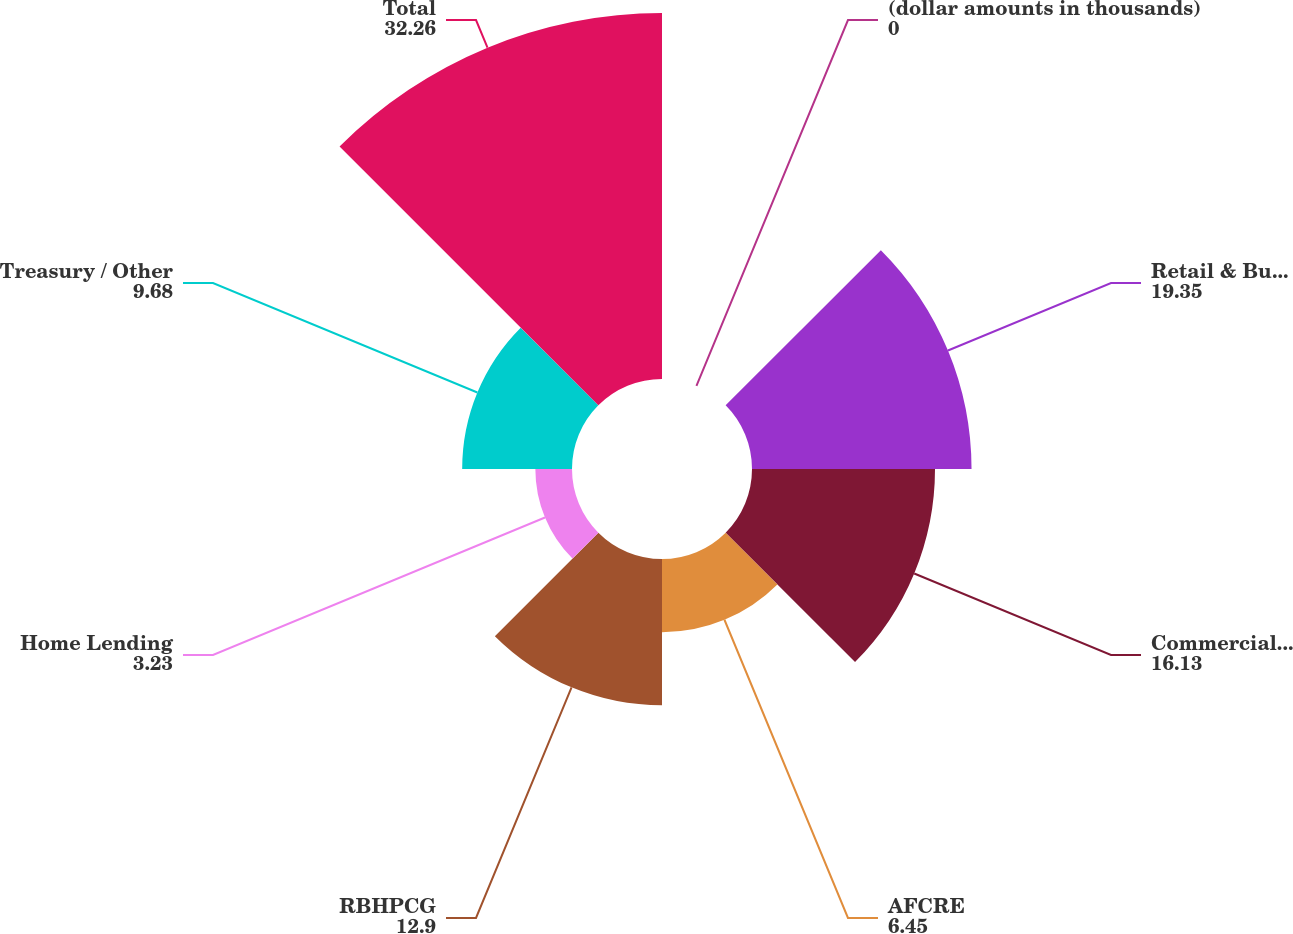<chart> <loc_0><loc_0><loc_500><loc_500><pie_chart><fcel>(dollar amounts in thousands)<fcel>Retail & Business Banking<fcel>Commercial Banking<fcel>AFCRE<fcel>RBHPCG<fcel>Home Lending<fcel>Treasury / Other<fcel>Total<nl><fcel>0.0%<fcel>19.35%<fcel>16.13%<fcel>6.45%<fcel>12.9%<fcel>3.23%<fcel>9.68%<fcel>32.26%<nl></chart> 